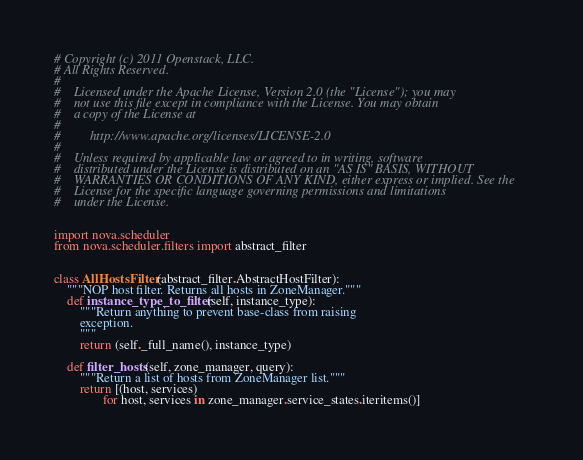<code> <loc_0><loc_0><loc_500><loc_500><_Python_># Copyright (c) 2011 Openstack, LLC.
# All Rights Reserved.
#
#    Licensed under the Apache License, Version 2.0 (the "License"); you may
#    not use this file except in compliance with the License. You may obtain
#    a copy of the License at
#
#         http://www.apache.org/licenses/LICENSE-2.0
#
#    Unless required by applicable law or agreed to in writing, software
#    distributed under the License is distributed on an "AS IS" BASIS, WITHOUT
#    WARRANTIES OR CONDITIONS OF ANY KIND, either express or implied. See the
#    License for the specific language governing permissions and limitations
#    under the License.


import nova.scheduler
from nova.scheduler.filters import abstract_filter


class AllHostsFilter(abstract_filter.AbstractHostFilter):
    """NOP host filter. Returns all hosts in ZoneManager."""
    def instance_type_to_filter(self, instance_type):
        """Return anything to prevent base-class from raising
        exception.
        """
        return (self._full_name(), instance_type)

    def filter_hosts(self, zone_manager, query):
        """Return a list of hosts from ZoneManager list."""
        return [(host, services)
               for host, services in zone_manager.service_states.iteritems()]
</code> 